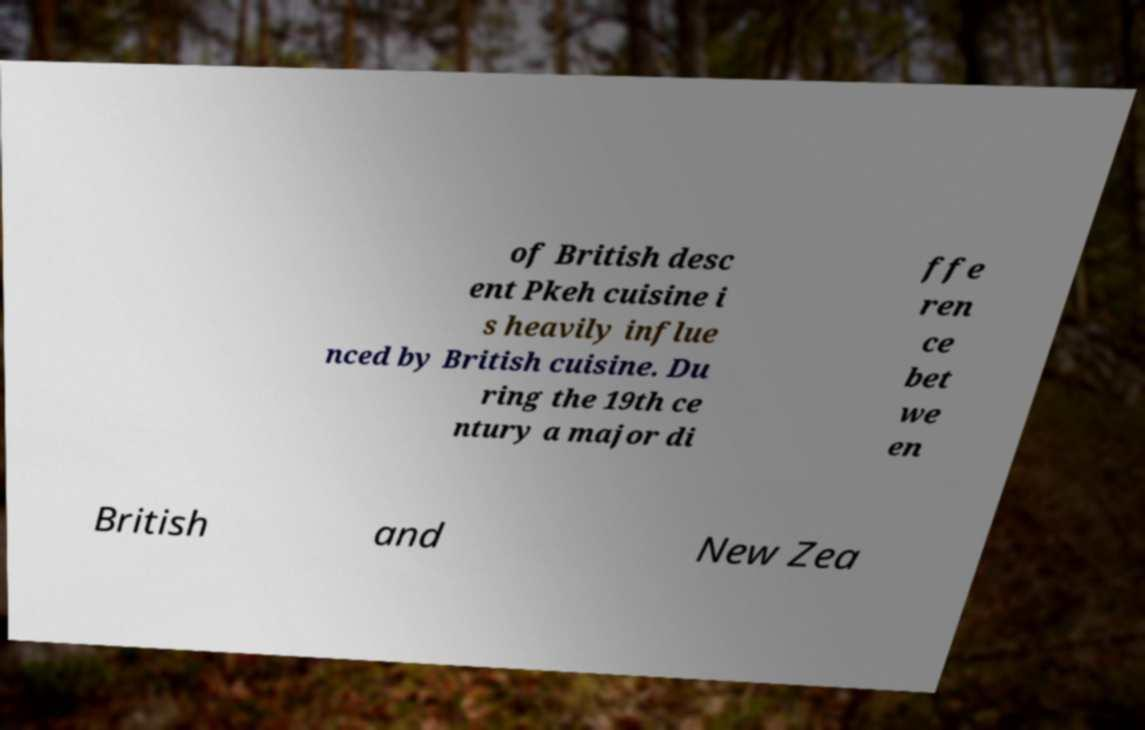For documentation purposes, I need the text within this image transcribed. Could you provide that? of British desc ent Pkeh cuisine i s heavily influe nced by British cuisine. Du ring the 19th ce ntury a major di ffe ren ce bet we en British and New Zea 